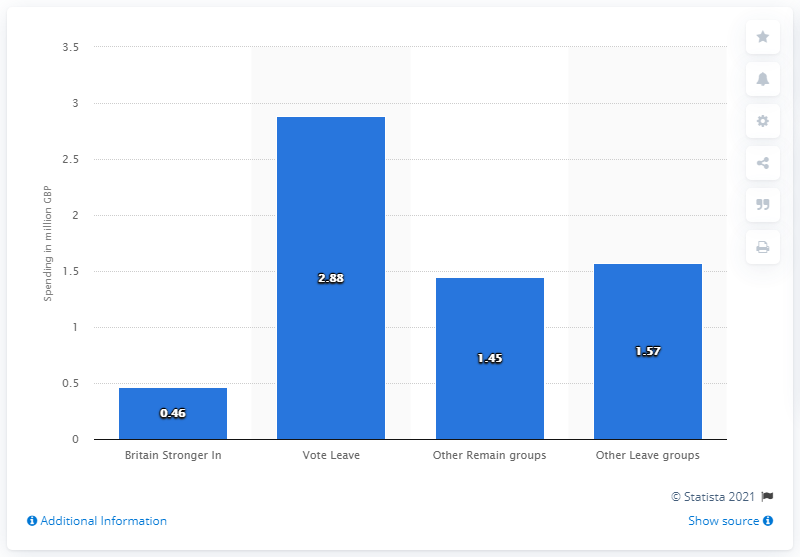Highlight a few significant elements in this photo. During the EU referendum campaign, Britain Stronger In spent 0.46 on their campaign efforts. 